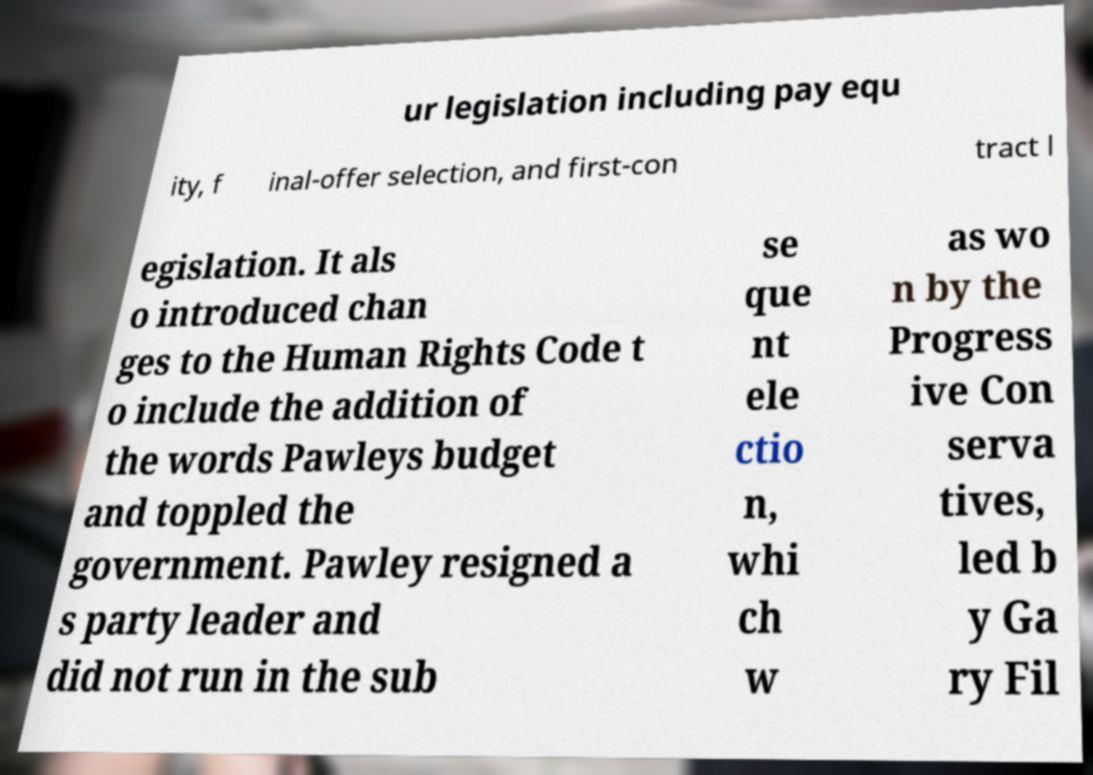I need the written content from this picture converted into text. Can you do that? ur legislation including pay equ ity, f inal-offer selection, and first-con tract l egislation. It als o introduced chan ges to the Human Rights Code t o include the addition of the words Pawleys budget and toppled the government. Pawley resigned a s party leader and did not run in the sub se que nt ele ctio n, whi ch w as wo n by the Progress ive Con serva tives, led b y Ga ry Fil 